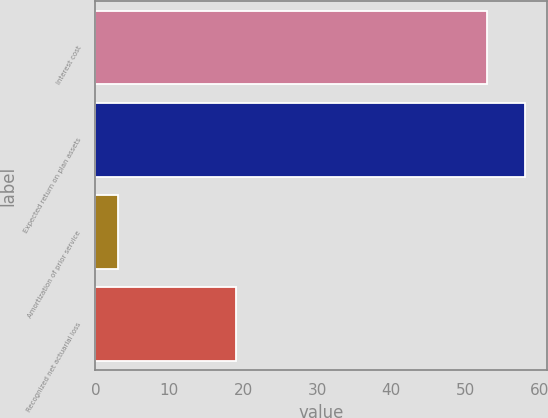<chart> <loc_0><loc_0><loc_500><loc_500><bar_chart><fcel>Interest cost<fcel>Expected return on plan assets<fcel>Amortization of prior service<fcel>Recognized net actuarial loss<nl><fcel>53<fcel>58.1<fcel>3<fcel>19<nl></chart> 